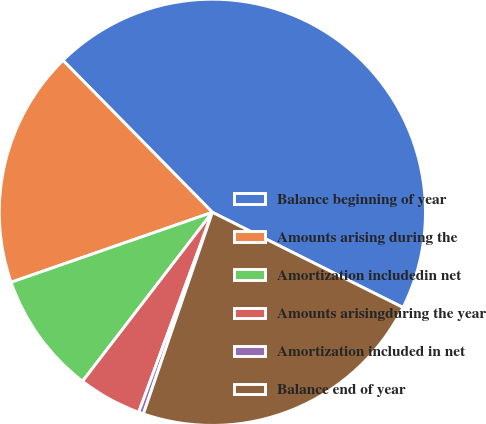Convert chart. <chart><loc_0><loc_0><loc_500><loc_500><pie_chart><fcel>Balance beginning of year<fcel>Amounts arising during the<fcel>Amortization includedin net<fcel>Amounts arisingduring the year<fcel>Amortization included in net<fcel>Balance end of year<nl><fcel>44.74%<fcel>17.96%<fcel>9.25%<fcel>4.81%<fcel>0.37%<fcel>22.88%<nl></chart> 